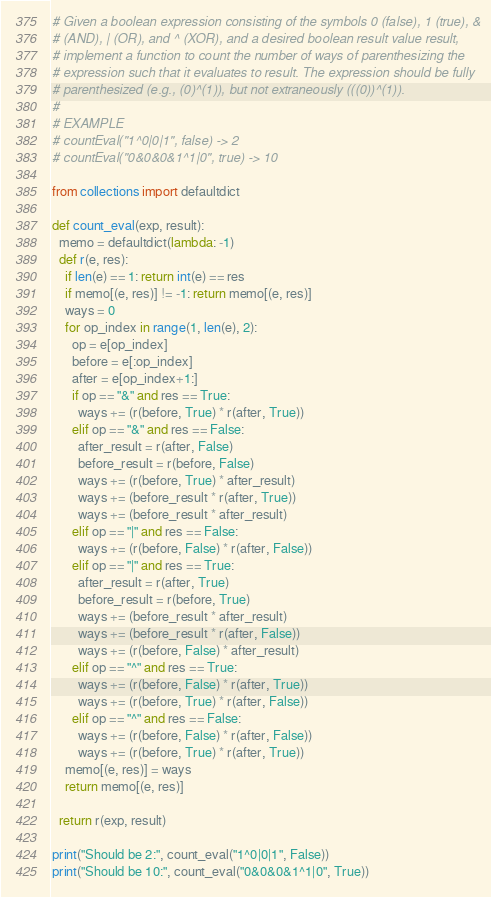<code> <loc_0><loc_0><loc_500><loc_500><_Python_># Given a boolean expression consisting of the symbols 0 (false), 1 (true), &
# (AND), | (OR), and ^ (XOR), and a desired boolean result value result,
# implement a function to count the number of ways of parenthesizing the
# expression such that it evaluates to result. The expression should be fully
# parenthesized (e.g., (0)^(1)), but not extraneously (((0))^(1)).
#
# EXAMPLE
# countEval("1^0|0|1", false) -> 2
# countEval("0&0&0&1^1|0", true) -> 10

from collections import defaultdict

def count_eval(exp, result):
  memo = defaultdict(lambda: -1)
  def r(e, res):
    if len(e) == 1: return int(e) == res
    if memo[(e, res)] != -1: return memo[(e, res)]
    ways = 0
    for op_index in range(1, len(e), 2):
      op = e[op_index]
      before = e[:op_index]
      after = e[op_index+1:]
      if op == "&" and res == True:
        ways += (r(before, True) * r(after, True))
      elif op == "&" and res == False:
        after_result = r(after, False)
        before_result = r(before, False)
        ways += (r(before, True) * after_result)
        ways += (before_result * r(after, True))
        ways += (before_result * after_result)
      elif op == "|" and res == False:
        ways += (r(before, False) * r(after, False))
      elif op == "|" and res == True:
        after_result = r(after, True)
        before_result = r(before, True)
        ways += (before_result * after_result)
        ways += (before_result * r(after, False))
        ways += (r(before, False) * after_result)
      elif op == "^" and res == True:
        ways += (r(before, False) * r(after, True))
        ways += (r(before, True) * r(after, False))
      elif op == "^" and res == False:
        ways += (r(before, False) * r(after, False))
        ways += (r(before, True) * r(after, True))
    memo[(e, res)] = ways
    return memo[(e, res)]

  return r(exp, result)

print("Should be 2:", count_eval("1^0|0|1", False))
print("Should be 10:", count_eval("0&0&0&1^1|0", True))

</code> 